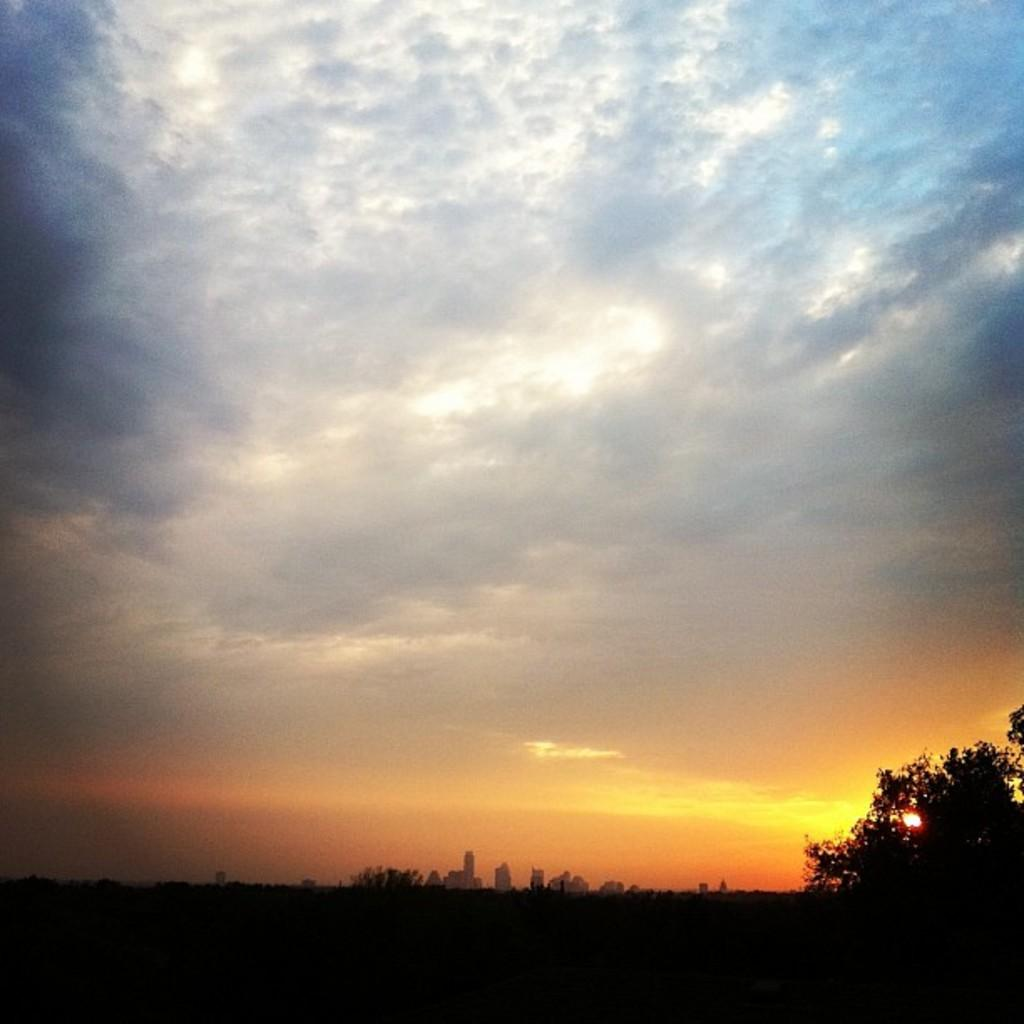What type of natural elements can be seen in the image? There are trees in the image. What type of man-made structures can be seen in the image? There are buildings in the image. What is visible in the background of the image? The sky is visible in the background of the image. How many visitors can be seen swimming in the image? There are no visitors or swimming activities present in the image. 